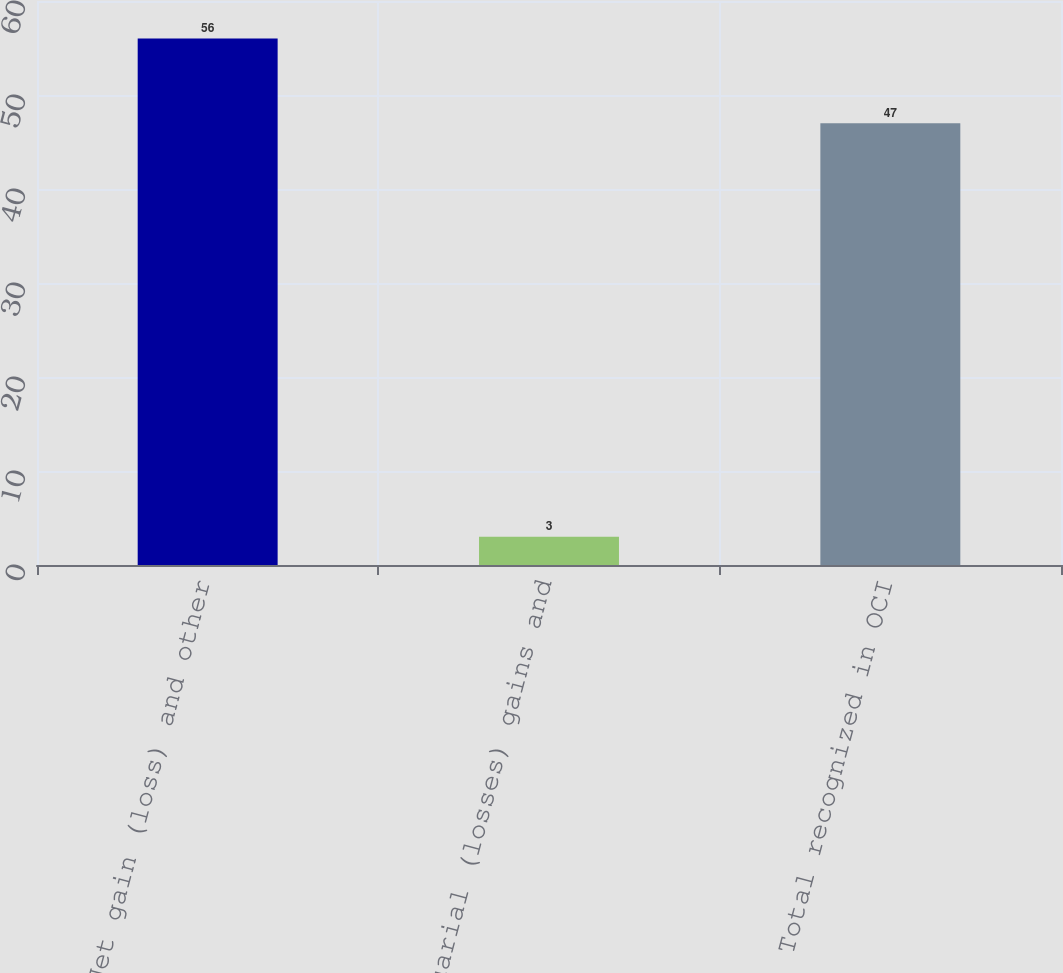Convert chart. <chart><loc_0><loc_0><loc_500><loc_500><bar_chart><fcel>Net gain (loss) and other<fcel>Actuarial (losses) gains and<fcel>Total recognized in OCI<nl><fcel>56<fcel>3<fcel>47<nl></chart> 